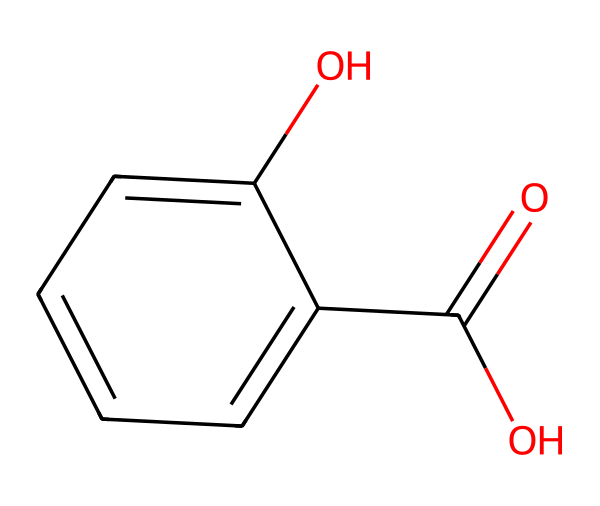What is the molecular formula of salicylic acid? To determine the molecular formula, count the number of each type of atom in the SMILES representation: there are 7 carbon atoms, 6 hydrogen atoms, and 3 oxygen atoms. The molecular formula combines these counts into a single expression: C7H6O3.
Answer: C7H6O3 How many hydroxyl groups are present in salicylic acid? In the chemical structure, the hydroxyl group (-OH) is represented by the "O" bonded to a carbon atom. There are 2 occurrences of such groups in the structure, indicating how many hydroxyl groups are present.
Answer: 2 What type of functional groups are present in salicylic acid? By examining the chemical structure, we can identify the functional groups. There is a carboxylic acid group (-COOH) and at least one hydroxyl group (-OH). Together, these groups denote its functionality.
Answer: carboxylic acid and hydroxyl Is salicylic acid an aromatic compound? The presence of a benzene ring (denoted by alternating double bonds in a cyclic structure) in salicylic acid indicates that it is an aromatic compound. This characteristic defines many features of its chemical behavior.
Answer: yes What is the significance of salicylic acid in plant responses? Salicylic acid is known to play a critical role in plant stress responses, particularly in defense mechanisms against pathogens due to its involvement in signaling pathways. This importance stems from its functions in plant physiology and biochemistry.
Answer: stress responses 